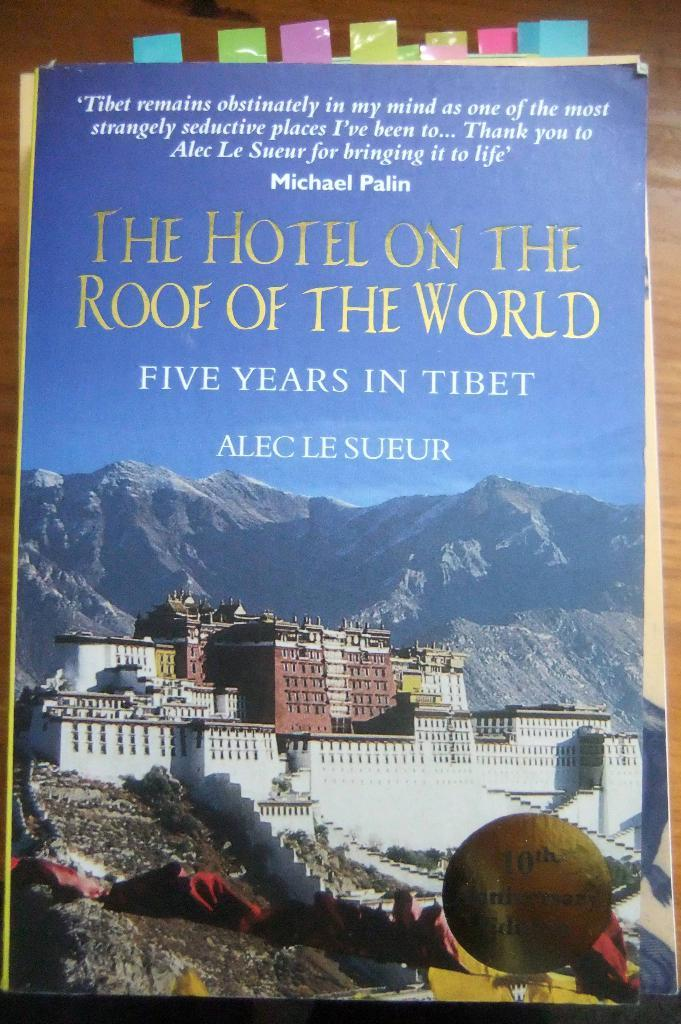<image>
Offer a succinct explanation of the picture presented. A book by Alec Le Sueur is titled The Hotel on the Roof of the World. 